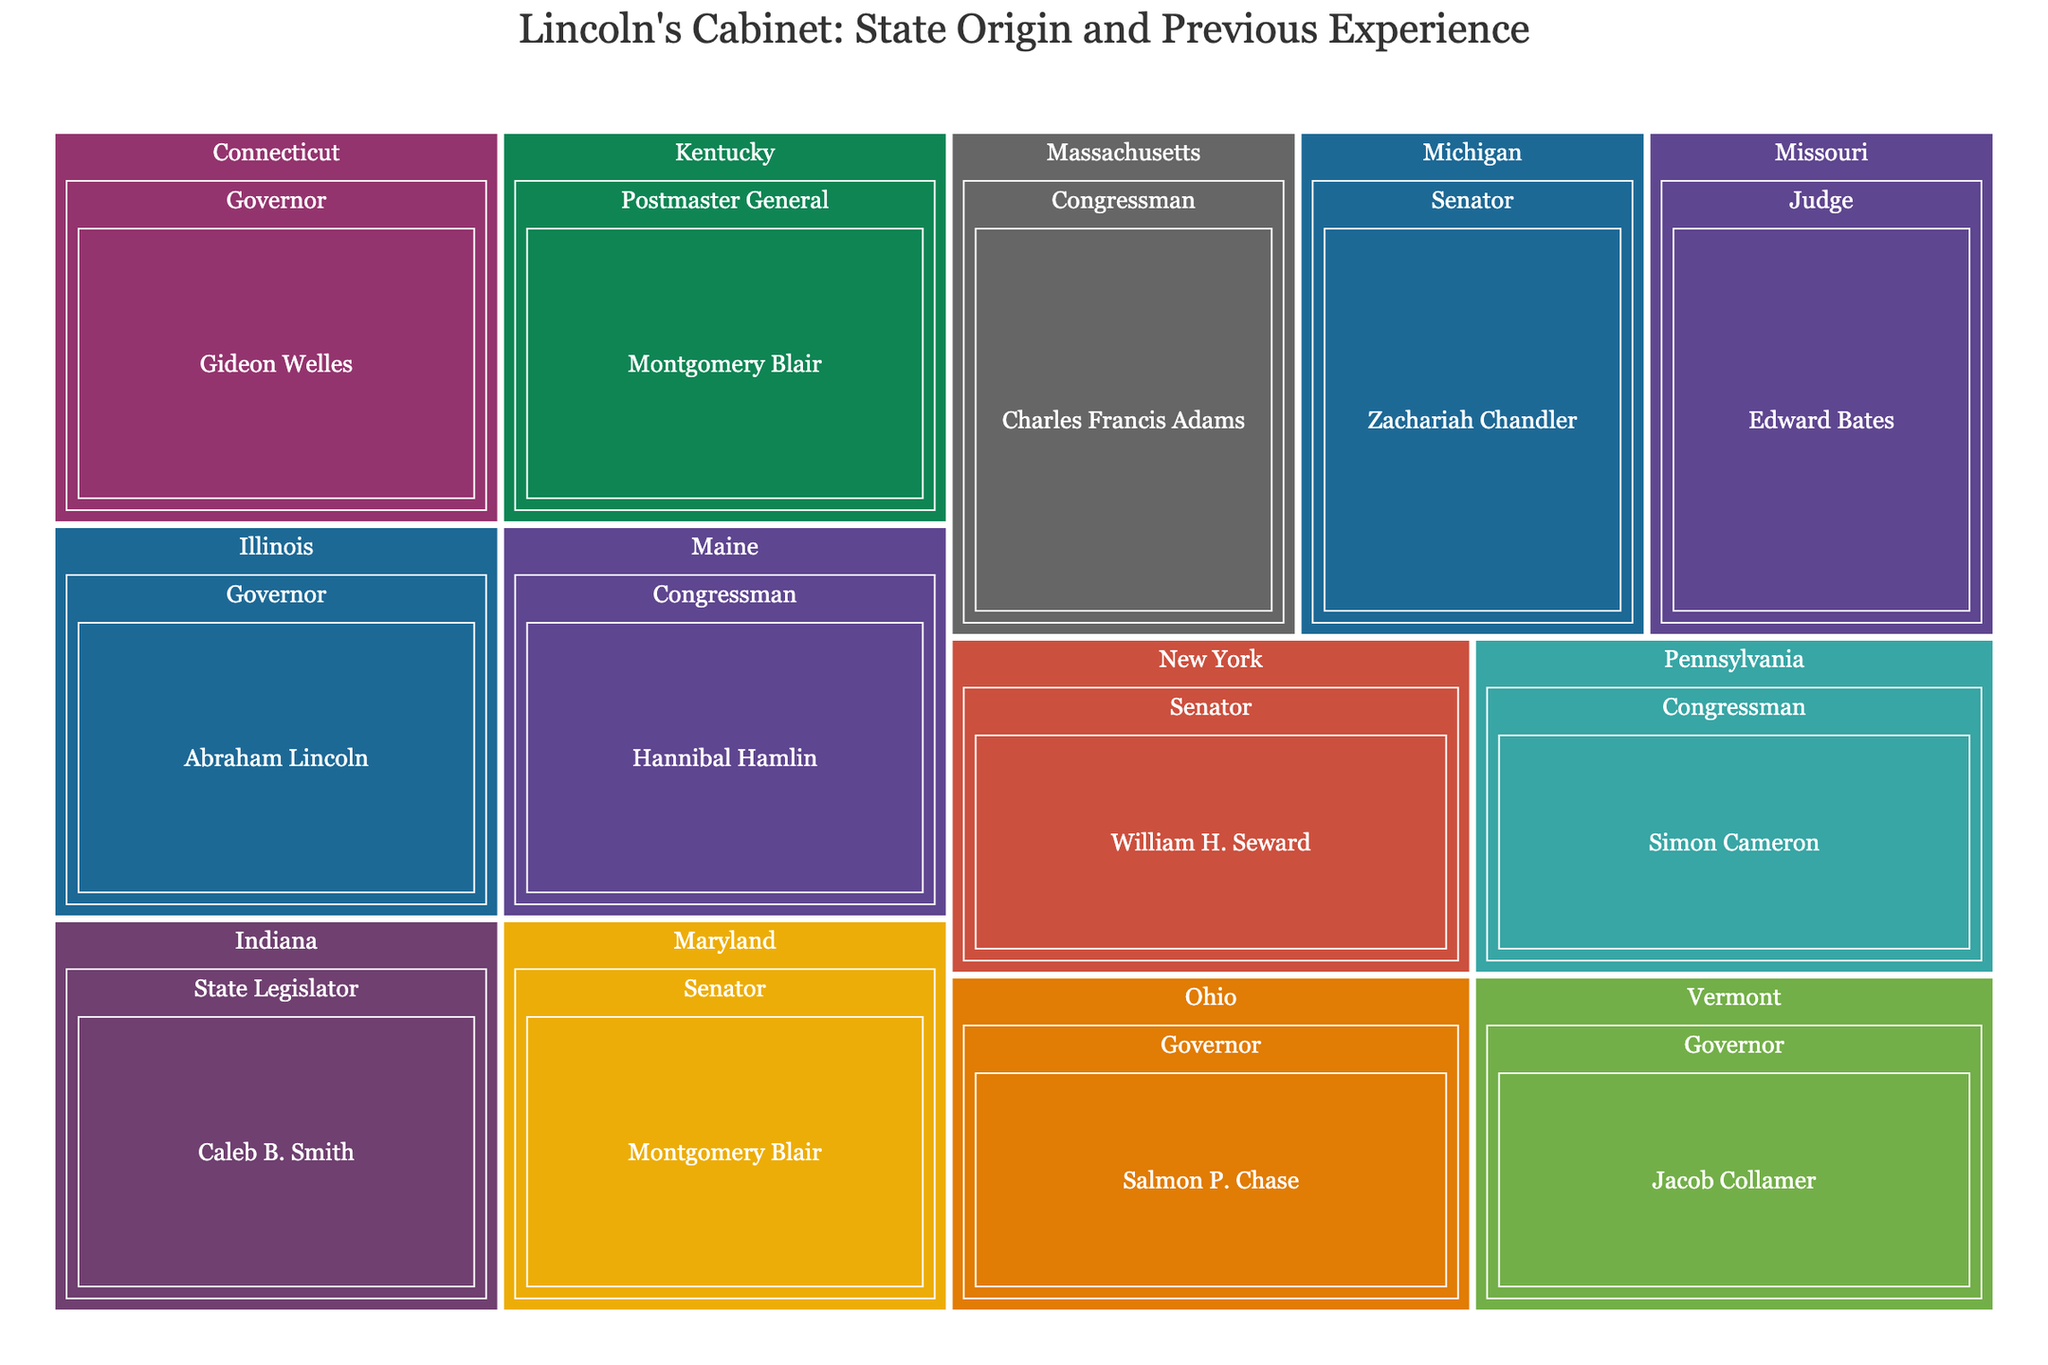What state is William H. Seward from? To find this, look at the segment labeled "William H. Seward" in the treemap. It is under the "New York" section.
Answer: New York How many Cabinet Members had previous experience as Governors? Identify all sections labeled "Governor" in the treemap. There are Abraham Lincoln, Salmon P. Chase, Gideon Welles, Jacob Collamer.
Answer: 4 Which state has the most variety in previous political experience for its Cabinet members? Look at the number of different segments (different previous experiences) within each state's section. Maryland has two different experience types under Montgomery Blair (Postmaster General and Senator).
Answer: Maryland Who is the Cabinet Member from Missouri, and what was his previous job? Find the "Missouri" section and look at the specific label within it. The label reads "Edward Bates" and his previous job title reads "Judge".
Answer: Edward Bates, Judge Compare the number of Cabinet Members from states originating from the Midwest to those from the Northeast. Identify all states typically considered in the Midwest (e.g., Illinois, Ohio, Indiana, Michigan). Then, do the same for the Northeast (e.g., New York, Pennsylvania, Connecticut, Maine, Massachusetts, Vermont). Midwest: Abraham Lincoln (Illinois), Salmon P. Chase (Ohio), Caleb B. Smith (Indiana), Zachariah Chandler (Michigan) = 4. Northeast: William H. Seward (New York), Simon Cameron (Pennsylvania), Gideon Welles (Connecticut), Hannibal Hamlin (Maine), Charles Francis Adams (Massachusetts), Jacob Collamer (Vermont) = 6.
Answer: Midwest: 4, Northeast: 6 Which Cabinet Member had previous experience as a Senator and is from New York? Locate the "Senator" section within the "New York" segment. This specific part corresponds to William H. Seward.
Answer: William H. Seward How many members served as Congressmen? Count all distinct segments labeled "Congressman" throughout the treemap. There are Simon Cameron, Hannibal Hamlin, Charles Francis Adams = 3.
Answer: 3 Which Cabinet Member from Kentucky had a different role than serving in Congress or the Senate? Identify the "Kentucky" section and see what previous role is listed under it. Montgomery Blair is labeled with a role of "Postmaster General" in Kentucky.
Answer: Montgomery Blair, Postmaster General How has the diversity of roles within states been represented visually? Examine how the treemap uses subdivisions within each state section to display different roles, showing multiple experiences if they exist.
Answer: Subdivisions within state sections represent different roles Does any state have more than one Cabinet Member listed? By examining each state's section, checking if any state has more than one name listed. Only Maryland has Montgomery Blair listed twice with different roles.
Answer: Maryland 